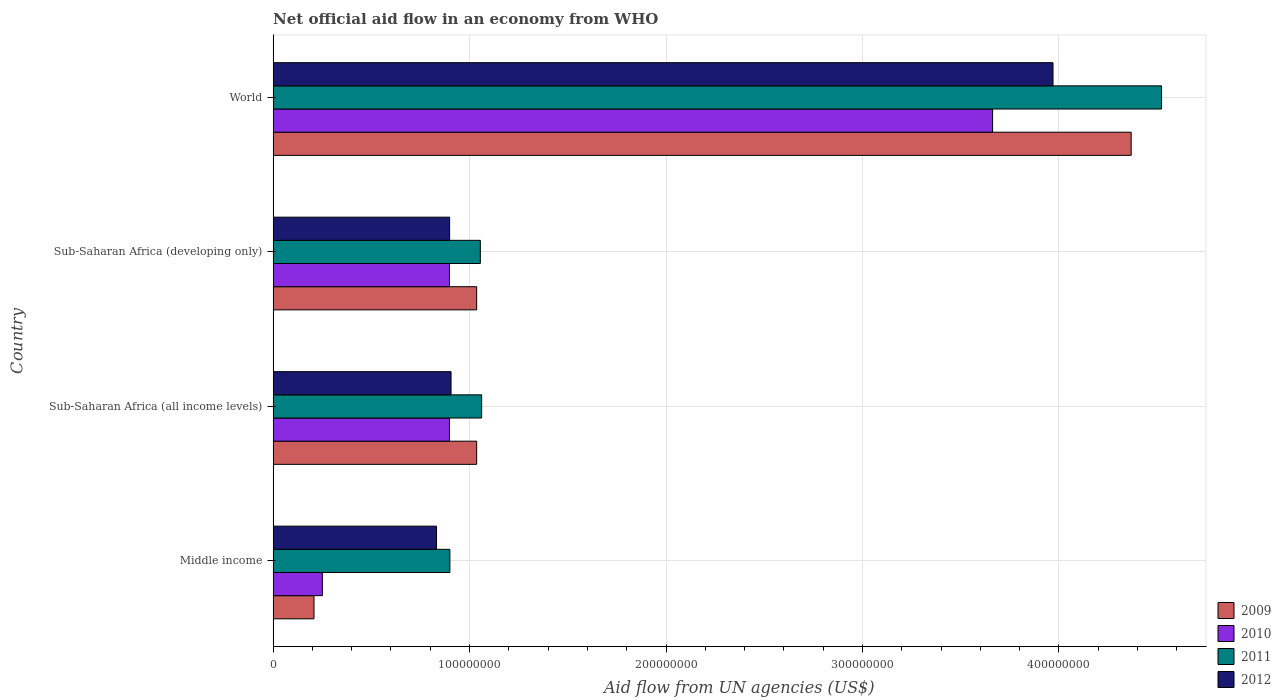How many different coloured bars are there?
Provide a short and direct response. 4. Are the number of bars on each tick of the Y-axis equal?
Provide a succinct answer. Yes. In how many cases, is the number of bars for a given country not equal to the number of legend labels?
Your response must be concise. 0. What is the net official aid flow in 2009 in Middle income?
Provide a short and direct response. 2.08e+07. Across all countries, what is the maximum net official aid flow in 2011?
Your response must be concise. 4.52e+08. Across all countries, what is the minimum net official aid flow in 2009?
Offer a terse response. 2.08e+07. In which country was the net official aid flow in 2009 minimum?
Your answer should be very brief. Middle income. What is the total net official aid flow in 2012 in the graph?
Provide a short and direct response. 6.61e+08. What is the difference between the net official aid flow in 2011 in Middle income and that in World?
Keep it short and to the point. -3.62e+08. What is the difference between the net official aid flow in 2011 in Middle income and the net official aid flow in 2010 in World?
Keep it short and to the point. -2.76e+08. What is the average net official aid flow in 2010 per country?
Provide a short and direct response. 1.43e+08. What is the difference between the net official aid flow in 2010 and net official aid flow in 2011 in Sub-Saharan Africa (developing only)?
Your answer should be very brief. -1.57e+07. What is the ratio of the net official aid flow in 2009 in Middle income to that in World?
Ensure brevity in your answer.  0.05. Is the net official aid flow in 2011 in Middle income less than that in World?
Give a very brief answer. Yes. Is the difference between the net official aid flow in 2010 in Sub-Saharan Africa (all income levels) and Sub-Saharan Africa (developing only) greater than the difference between the net official aid flow in 2011 in Sub-Saharan Africa (all income levels) and Sub-Saharan Africa (developing only)?
Provide a succinct answer. No. What is the difference between the highest and the second highest net official aid flow in 2012?
Provide a short and direct response. 3.06e+08. What is the difference between the highest and the lowest net official aid flow in 2009?
Your answer should be compact. 4.16e+08. In how many countries, is the net official aid flow in 2012 greater than the average net official aid flow in 2012 taken over all countries?
Your answer should be very brief. 1. Is the sum of the net official aid flow in 2012 in Sub-Saharan Africa (all income levels) and World greater than the maximum net official aid flow in 2009 across all countries?
Make the answer very short. Yes. What does the 4th bar from the top in World represents?
Offer a very short reply. 2009. What does the 1st bar from the bottom in Sub-Saharan Africa (developing only) represents?
Your answer should be very brief. 2009. Are all the bars in the graph horizontal?
Ensure brevity in your answer.  Yes. How many countries are there in the graph?
Offer a terse response. 4. Are the values on the major ticks of X-axis written in scientific E-notation?
Give a very brief answer. No. Does the graph contain grids?
Offer a terse response. Yes. What is the title of the graph?
Your response must be concise. Net official aid flow in an economy from WHO. Does "1986" appear as one of the legend labels in the graph?
Offer a very short reply. No. What is the label or title of the X-axis?
Ensure brevity in your answer.  Aid flow from UN agencies (US$). What is the Aid flow from UN agencies (US$) of 2009 in Middle income?
Ensure brevity in your answer.  2.08e+07. What is the Aid flow from UN agencies (US$) of 2010 in Middle income?
Keep it short and to the point. 2.51e+07. What is the Aid flow from UN agencies (US$) in 2011 in Middle income?
Make the answer very short. 9.00e+07. What is the Aid flow from UN agencies (US$) of 2012 in Middle income?
Your answer should be compact. 8.32e+07. What is the Aid flow from UN agencies (US$) of 2009 in Sub-Saharan Africa (all income levels)?
Your response must be concise. 1.04e+08. What is the Aid flow from UN agencies (US$) in 2010 in Sub-Saharan Africa (all income levels)?
Your answer should be compact. 8.98e+07. What is the Aid flow from UN agencies (US$) in 2011 in Sub-Saharan Africa (all income levels)?
Provide a short and direct response. 1.06e+08. What is the Aid flow from UN agencies (US$) in 2012 in Sub-Saharan Africa (all income levels)?
Your response must be concise. 9.06e+07. What is the Aid flow from UN agencies (US$) of 2009 in Sub-Saharan Africa (developing only)?
Give a very brief answer. 1.04e+08. What is the Aid flow from UN agencies (US$) of 2010 in Sub-Saharan Africa (developing only)?
Keep it short and to the point. 8.98e+07. What is the Aid flow from UN agencies (US$) in 2011 in Sub-Saharan Africa (developing only)?
Your answer should be very brief. 1.05e+08. What is the Aid flow from UN agencies (US$) of 2012 in Sub-Saharan Africa (developing only)?
Your answer should be compact. 8.98e+07. What is the Aid flow from UN agencies (US$) of 2009 in World?
Your answer should be compact. 4.37e+08. What is the Aid flow from UN agencies (US$) in 2010 in World?
Give a very brief answer. 3.66e+08. What is the Aid flow from UN agencies (US$) in 2011 in World?
Your response must be concise. 4.52e+08. What is the Aid flow from UN agencies (US$) of 2012 in World?
Provide a short and direct response. 3.97e+08. Across all countries, what is the maximum Aid flow from UN agencies (US$) in 2009?
Provide a short and direct response. 4.37e+08. Across all countries, what is the maximum Aid flow from UN agencies (US$) of 2010?
Your answer should be compact. 3.66e+08. Across all countries, what is the maximum Aid flow from UN agencies (US$) of 2011?
Your answer should be very brief. 4.52e+08. Across all countries, what is the maximum Aid flow from UN agencies (US$) of 2012?
Provide a short and direct response. 3.97e+08. Across all countries, what is the minimum Aid flow from UN agencies (US$) of 2009?
Provide a short and direct response. 2.08e+07. Across all countries, what is the minimum Aid flow from UN agencies (US$) of 2010?
Give a very brief answer. 2.51e+07. Across all countries, what is the minimum Aid flow from UN agencies (US$) in 2011?
Your answer should be compact. 9.00e+07. Across all countries, what is the minimum Aid flow from UN agencies (US$) of 2012?
Ensure brevity in your answer.  8.32e+07. What is the total Aid flow from UN agencies (US$) of 2009 in the graph?
Provide a short and direct response. 6.65e+08. What is the total Aid flow from UN agencies (US$) in 2010 in the graph?
Ensure brevity in your answer.  5.71e+08. What is the total Aid flow from UN agencies (US$) in 2011 in the graph?
Keep it short and to the point. 7.54e+08. What is the total Aid flow from UN agencies (US$) in 2012 in the graph?
Ensure brevity in your answer.  6.61e+08. What is the difference between the Aid flow from UN agencies (US$) of 2009 in Middle income and that in Sub-Saharan Africa (all income levels)?
Give a very brief answer. -8.28e+07. What is the difference between the Aid flow from UN agencies (US$) of 2010 in Middle income and that in Sub-Saharan Africa (all income levels)?
Provide a short and direct response. -6.47e+07. What is the difference between the Aid flow from UN agencies (US$) in 2011 in Middle income and that in Sub-Saharan Africa (all income levels)?
Give a very brief answer. -1.62e+07. What is the difference between the Aid flow from UN agencies (US$) of 2012 in Middle income and that in Sub-Saharan Africa (all income levels)?
Offer a very short reply. -7.39e+06. What is the difference between the Aid flow from UN agencies (US$) in 2009 in Middle income and that in Sub-Saharan Africa (developing only)?
Keep it short and to the point. -8.28e+07. What is the difference between the Aid flow from UN agencies (US$) of 2010 in Middle income and that in Sub-Saharan Africa (developing only)?
Provide a succinct answer. -6.47e+07. What is the difference between the Aid flow from UN agencies (US$) in 2011 in Middle income and that in Sub-Saharan Africa (developing only)?
Provide a short and direct response. -1.55e+07. What is the difference between the Aid flow from UN agencies (US$) of 2012 in Middle income and that in Sub-Saharan Africa (developing only)?
Ensure brevity in your answer.  -6.67e+06. What is the difference between the Aid flow from UN agencies (US$) of 2009 in Middle income and that in World?
Make the answer very short. -4.16e+08. What is the difference between the Aid flow from UN agencies (US$) in 2010 in Middle income and that in World?
Provide a succinct answer. -3.41e+08. What is the difference between the Aid flow from UN agencies (US$) of 2011 in Middle income and that in World?
Offer a terse response. -3.62e+08. What is the difference between the Aid flow from UN agencies (US$) of 2012 in Middle income and that in World?
Your answer should be very brief. -3.14e+08. What is the difference between the Aid flow from UN agencies (US$) of 2009 in Sub-Saharan Africa (all income levels) and that in Sub-Saharan Africa (developing only)?
Make the answer very short. 0. What is the difference between the Aid flow from UN agencies (US$) in 2011 in Sub-Saharan Africa (all income levels) and that in Sub-Saharan Africa (developing only)?
Your answer should be very brief. 6.70e+05. What is the difference between the Aid flow from UN agencies (US$) of 2012 in Sub-Saharan Africa (all income levels) and that in Sub-Saharan Africa (developing only)?
Provide a short and direct response. 7.20e+05. What is the difference between the Aid flow from UN agencies (US$) of 2009 in Sub-Saharan Africa (all income levels) and that in World?
Ensure brevity in your answer.  -3.33e+08. What is the difference between the Aid flow from UN agencies (US$) of 2010 in Sub-Saharan Africa (all income levels) and that in World?
Offer a terse response. -2.76e+08. What is the difference between the Aid flow from UN agencies (US$) of 2011 in Sub-Saharan Africa (all income levels) and that in World?
Provide a succinct answer. -3.46e+08. What is the difference between the Aid flow from UN agencies (US$) of 2012 in Sub-Saharan Africa (all income levels) and that in World?
Your answer should be compact. -3.06e+08. What is the difference between the Aid flow from UN agencies (US$) in 2009 in Sub-Saharan Africa (developing only) and that in World?
Offer a terse response. -3.33e+08. What is the difference between the Aid flow from UN agencies (US$) of 2010 in Sub-Saharan Africa (developing only) and that in World?
Offer a terse response. -2.76e+08. What is the difference between the Aid flow from UN agencies (US$) in 2011 in Sub-Saharan Africa (developing only) and that in World?
Give a very brief answer. -3.47e+08. What is the difference between the Aid flow from UN agencies (US$) in 2012 in Sub-Saharan Africa (developing only) and that in World?
Provide a short and direct response. -3.07e+08. What is the difference between the Aid flow from UN agencies (US$) of 2009 in Middle income and the Aid flow from UN agencies (US$) of 2010 in Sub-Saharan Africa (all income levels)?
Make the answer very short. -6.90e+07. What is the difference between the Aid flow from UN agencies (US$) in 2009 in Middle income and the Aid flow from UN agencies (US$) in 2011 in Sub-Saharan Africa (all income levels)?
Ensure brevity in your answer.  -8.54e+07. What is the difference between the Aid flow from UN agencies (US$) in 2009 in Middle income and the Aid flow from UN agencies (US$) in 2012 in Sub-Saharan Africa (all income levels)?
Ensure brevity in your answer.  -6.98e+07. What is the difference between the Aid flow from UN agencies (US$) in 2010 in Middle income and the Aid flow from UN agencies (US$) in 2011 in Sub-Saharan Africa (all income levels)?
Your response must be concise. -8.11e+07. What is the difference between the Aid flow from UN agencies (US$) in 2010 in Middle income and the Aid flow from UN agencies (US$) in 2012 in Sub-Saharan Africa (all income levels)?
Make the answer very short. -6.55e+07. What is the difference between the Aid flow from UN agencies (US$) of 2011 in Middle income and the Aid flow from UN agencies (US$) of 2012 in Sub-Saharan Africa (all income levels)?
Make the answer very short. -5.90e+05. What is the difference between the Aid flow from UN agencies (US$) of 2009 in Middle income and the Aid flow from UN agencies (US$) of 2010 in Sub-Saharan Africa (developing only)?
Your response must be concise. -6.90e+07. What is the difference between the Aid flow from UN agencies (US$) of 2009 in Middle income and the Aid flow from UN agencies (US$) of 2011 in Sub-Saharan Africa (developing only)?
Make the answer very short. -8.47e+07. What is the difference between the Aid flow from UN agencies (US$) in 2009 in Middle income and the Aid flow from UN agencies (US$) in 2012 in Sub-Saharan Africa (developing only)?
Provide a short and direct response. -6.90e+07. What is the difference between the Aid flow from UN agencies (US$) of 2010 in Middle income and the Aid flow from UN agencies (US$) of 2011 in Sub-Saharan Africa (developing only)?
Provide a succinct answer. -8.04e+07. What is the difference between the Aid flow from UN agencies (US$) in 2010 in Middle income and the Aid flow from UN agencies (US$) in 2012 in Sub-Saharan Africa (developing only)?
Offer a terse response. -6.48e+07. What is the difference between the Aid flow from UN agencies (US$) of 2011 in Middle income and the Aid flow from UN agencies (US$) of 2012 in Sub-Saharan Africa (developing only)?
Your answer should be compact. 1.30e+05. What is the difference between the Aid flow from UN agencies (US$) of 2009 in Middle income and the Aid flow from UN agencies (US$) of 2010 in World?
Your answer should be compact. -3.45e+08. What is the difference between the Aid flow from UN agencies (US$) in 2009 in Middle income and the Aid flow from UN agencies (US$) in 2011 in World?
Make the answer very short. -4.31e+08. What is the difference between the Aid flow from UN agencies (US$) of 2009 in Middle income and the Aid flow from UN agencies (US$) of 2012 in World?
Ensure brevity in your answer.  -3.76e+08. What is the difference between the Aid flow from UN agencies (US$) in 2010 in Middle income and the Aid flow from UN agencies (US$) in 2011 in World?
Ensure brevity in your answer.  -4.27e+08. What is the difference between the Aid flow from UN agencies (US$) in 2010 in Middle income and the Aid flow from UN agencies (US$) in 2012 in World?
Offer a very short reply. -3.72e+08. What is the difference between the Aid flow from UN agencies (US$) of 2011 in Middle income and the Aid flow from UN agencies (US$) of 2012 in World?
Your answer should be compact. -3.07e+08. What is the difference between the Aid flow from UN agencies (US$) of 2009 in Sub-Saharan Africa (all income levels) and the Aid flow from UN agencies (US$) of 2010 in Sub-Saharan Africa (developing only)?
Make the answer very short. 1.39e+07. What is the difference between the Aid flow from UN agencies (US$) in 2009 in Sub-Saharan Africa (all income levels) and the Aid flow from UN agencies (US$) in 2011 in Sub-Saharan Africa (developing only)?
Your answer should be compact. -1.86e+06. What is the difference between the Aid flow from UN agencies (US$) of 2009 in Sub-Saharan Africa (all income levels) and the Aid flow from UN agencies (US$) of 2012 in Sub-Saharan Africa (developing only)?
Your response must be concise. 1.38e+07. What is the difference between the Aid flow from UN agencies (US$) in 2010 in Sub-Saharan Africa (all income levels) and the Aid flow from UN agencies (US$) in 2011 in Sub-Saharan Africa (developing only)?
Offer a very short reply. -1.57e+07. What is the difference between the Aid flow from UN agencies (US$) of 2010 in Sub-Saharan Africa (all income levels) and the Aid flow from UN agencies (US$) of 2012 in Sub-Saharan Africa (developing only)?
Provide a succinct answer. -9.00e+04. What is the difference between the Aid flow from UN agencies (US$) in 2011 in Sub-Saharan Africa (all income levels) and the Aid flow from UN agencies (US$) in 2012 in Sub-Saharan Africa (developing only)?
Your answer should be compact. 1.63e+07. What is the difference between the Aid flow from UN agencies (US$) in 2009 in Sub-Saharan Africa (all income levels) and the Aid flow from UN agencies (US$) in 2010 in World?
Your answer should be very brief. -2.63e+08. What is the difference between the Aid flow from UN agencies (US$) of 2009 in Sub-Saharan Africa (all income levels) and the Aid flow from UN agencies (US$) of 2011 in World?
Provide a short and direct response. -3.49e+08. What is the difference between the Aid flow from UN agencies (US$) of 2009 in Sub-Saharan Africa (all income levels) and the Aid flow from UN agencies (US$) of 2012 in World?
Your response must be concise. -2.93e+08. What is the difference between the Aid flow from UN agencies (US$) in 2010 in Sub-Saharan Africa (all income levels) and the Aid flow from UN agencies (US$) in 2011 in World?
Your answer should be very brief. -3.62e+08. What is the difference between the Aid flow from UN agencies (US$) of 2010 in Sub-Saharan Africa (all income levels) and the Aid flow from UN agencies (US$) of 2012 in World?
Your answer should be compact. -3.07e+08. What is the difference between the Aid flow from UN agencies (US$) of 2011 in Sub-Saharan Africa (all income levels) and the Aid flow from UN agencies (US$) of 2012 in World?
Offer a very short reply. -2.91e+08. What is the difference between the Aid flow from UN agencies (US$) in 2009 in Sub-Saharan Africa (developing only) and the Aid flow from UN agencies (US$) in 2010 in World?
Make the answer very short. -2.63e+08. What is the difference between the Aid flow from UN agencies (US$) in 2009 in Sub-Saharan Africa (developing only) and the Aid flow from UN agencies (US$) in 2011 in World?
Make the answer very short. -3.49e+08. What is the difference between the Aid flow from UN agencies (US$) in 2009 in Sub-Saharan Africa (developing only) and the Aid flow from UN agencies (US$) in 2012 in World?
Your response must be concise. -2.93e+08. What is the difference between the Aid flow from UN agencies (US$) in 2010 in Sub-Saharan Africa (developing only) and the Aid flow from UN agencies (US$) in 2011 in World?
Your answer should be compact. -3.62e+08. What is the difference between the Aid flow from UN agencies (US$) in 2010 in Sub-Saharan Africa (developing only) and the Aid flow from UN agencies (US$) in 2012 in World?
Your response must be concise. -3.07e+08. What is the difference between the Aid flow from UN agencies (US$) of 2011 in Sub-Saharan Africa (developing only) and the Aid flow from UN agencies (US$) of 2012 in World?
Provide a short and direct response. -2.92e+08. What is the average Aid flow from UN agencies (US$) in 2009 per country?
Ensure brevity in your answer.  1.66e+08. What is the average Aid flow from UN agencies (US$) of 2010 per country?
Your answer should be compact. 1.43e+08. What is the average Aid flow from UN agencies (US$) in 2011 per country?
Your response must be concise. 1.88e+08. What is the average Aid flow from UN agencies (US$) in 2012 per country?
Ensure brevity in your answer.  1.65e+08. What is the difference between the Aid flow from UN agencies (US$) in 2009 and Aid flow from UN agencies (US$) in 2010 in Middle income?
Give a very brief answer. -4.27e+06. What is the difference between the Aid flow from UN agencies (US$) of 2009 and Aid flow from UN agencies (US$) of 2011 in Middle income?
Keep it short and to the point. -6.92e+07. What is the difference between the Aid flow from UN agencies (US$) in 2009 and Aid flow from UN agencies (US$) in 2012 in Middle income?
Your answer should be very brief. -6.24e+07. What is the difference between the Aid flow from UN agencies (US$) in 2010 and Aid flow from UN agencies (US$) in 2011 in Middle income?
Ensure brevity in your answer.  -6.49e+07. What is the difference between the Aid flow from UN agencies (US$) in 2010 and Aid flow from UN agencies (US$) in 2012 in Middle income?
Provide a succinct answer. -5.81e+07. What is the difference between the Aid flow from UN agencies (US$) of 2011 and Aid flow from UN agencies (US$) of 2012 in Middle income?
Ensure brevity in your answer.  6.80e+06. What is the difference between the Aid flow from UN agencies (US$) of 2009 and Aid flow from UN agencies (US$) of 2010 in Sub-Saharan Africa (all income levels)?
Provide a succinct answer. 1.39e+07. What is the difference between the Aid flow from UN agencies (US$) of 2009 and Aid flow from UN agencies (US$) of 2011 in Sub-Saharan Africa (all income levels)?
Make the answer very short. -2.53e+06. What is the difference between the Aid flow from UN agencies (US$) of 2009 and Aid flow from UN agencies (US$) of 2012 in Sub-Saharan Africa (all income levels)?
Keep it short and to the point. 1.30e+07. What is the difference between the Aid flow from UN agencies (US$) of 2010 and Aid flow from UN agencies (US$) of 2011 in Sub-Saharan Africa (all income levels)?
Your answer should be very brief. -1.64e+07. What is the difference between the Aid flow from UN agencies (US$) of 2010 and Aid flow from UN agencies (US$) of 2012 in Sub-Saharan Africa (all income levels)?
Your answer should be very brief. -8.10e+05. What is the difference between the Aid flow from UN agencies (US$) of 2011 and Aid flow from UN agencies (US$) of 2012 in Sub-Saharan Africa (all income levels)?
Your answer should be very brief. 1.56e+07. What is the difference between the Aid flow from UN agencies (US$) in 2009 and Aid flow from UN agencies (US$) in 2010 in Sub-Saharan Africa (developing only)?
Your response must be concise. 1.39e+07. What is the difference between the Aid flow from UN agencies (US$) of 2009 and Aid flow from UN agencies (US$) of 2011 in Sub-Saharan Africa (developing only)?
Keep it short and to the point. -1.86e+06. What is the difference between the Aid flow from UN agencies (US$) of 2009 and Aid flow from UN agencies (US$) of 2012 in Sub-Saharan Africa (developing only)?
Provide a succinct answer. 1.38e+07. What is the difference between the Aid flow from UN agencies (US$) in 2010 and Aid flow from UN agencies (US$) in 2011 in Sub-Saharan Africa (developing only)?
Offer a terse response. -1.57e+07. What is the difference between the Aid flow from UN agencies (US$) of 2011 and Aid flow from UN agencies (US$) of 2012 in Sub-Saharan Africa (developing only)?
Offer a terse response. 1.56e+07. What is the difference between the Aid flow from UN agencies (US$) of 2009 and Aid flow from UN agencies (US$) of 2010 in World?
Give a very brief answer. 7.06e+07. What is the difference between the Aid flow from UN agencies (US$) in 2009 and Aid flow from UN agencies (US$) in 2011 in World?
Your answer should be very brief. -1.55e+07. What is the difference between the Aid flow from UN agencies (US$) in 2009 and Aid flow from UN agencies (US$) in 2012 in World?
Your response must be concise. 3.98e+07. What is the difference between the Aid flow from UN agencies (US$) of 2010 and Aid flow from UN agencies (US$) of 2011 in World?
Offer a very short reply. -8.60e+07. What is the difference between the Aid flow from UN agencies (US$) of 2010 and Aid flow from UN agencies (US$) of 2012 in World?
Provide a short and direct response. -3.08e+07. What is the difference between the Aid flow from UN agencies (US$) of 2011 and Aid flow from UN agencies (US$) of 2012 in World?
Your answer should be very brief. 5.53e+07. What is the ratio of the Aid flow from UN agencies (US$) in 2009 in Middle income to that in Sub-Saharan Africa (all income levels)?
Ensure brevity in your answer.  0.2. What is the ratio of the Aid flow from UN agencies (US$) in 2010 in Middle income to that in Sub-Saharan Africa (all income levels)?
Give a very brief answer. 0.28. What is the ratio of the Aid flow from UN agencies (US$) in 2011 in Middle income to that in Sub-Saharan Africa (all income levels)?
Ensure brevity in your answer.  0.85. What is the ratio of the Aid flow from UN agencies (US$) of 2012 in Middle income to that in Sub-Saharan Africa (all income levels)?
Give a very brief answer. 0.92. What is the ratio of the Aid flow from UN agencies (US$) of 2009 in Middle income to that in Sub-Saharan Africa (developing only)?
Make the answer very short. 0.2. What is the ratio of the Aid flow from UN agencies (US$) of 2010 in Middle income to that in Sub-Saharan Africa (developing only)?
Ensure brevity in your answer.  0.28. What is the ratio of the Aid flow from UN agencies (US$) of 2011 in Middle income to that in Sub-Saharan Africa (developing only)?
Offer a terse response. 0.85. What is the ratio of the Aid flow from UN agencies (US$) in 2012 in Middle income to that in Sub-Saharan Africa (developing only)?
Your response must be concise. 0.93. What is the ratio of the Aid flow from UN agencies (US$) in 2009 in Middle income to that in World?
Make the answer very short. 0.05. What is the ratio of the Aid flow from UN agencies (US$) of 2010 in Middle income to that in World?
Keep it short and to the point. 0.07. What is the ratio of the Aid flow from UN agencies (US$) in 2011 in Middle income to that in World?
Your answer should be very brief. 0.2. What is the ratio of the Aid flow from UN agencies (US$) of 2012 in Middle income to that in World?
Ensure brevity in your answer.  0.21. What is the ratio of the Aid flow from UN agencies (US$) of 2009 in Sub-Saharan Africa (all income levels) to that in Sub-Saharan Africa (developing only)?
Your response must be concise. 1. What is the ratio of the Aid flow from UN agencies (US$) of 2011 in Sub-Saharan Africa (all income levels) to that in Sub-Saharan Africa (developing only)?
Your answer should be compact. 1.01. What is the ratio of the Aid flow from UN agencies (US$) of 2009 in Sub-Saharan Africa (all income levels) to that in World?
Keep it short and to the point. 0.24. What is the ratio of the Aid flow from UN agencies (US$) in 2010 in Sub-Saharan Africa (all income levels) to that in World?
Make the answer very short. 0.25. What is the ratio of the Aid flow from UN agencies (US$) in 2011 in Sub-Saharan Africa (all income levels) to that in World?
Your response must be concise. 0.23. What is the ratio of the Aid flow from UN agencies (US$) in 2012 in Sub-Saharan Africa (all income levels) to that in World?
Your answer should be very brief. 0.23. What is the ratio of the Aid flow from UN agencies (US$) in 2009 in Sub-Saharan Africa (developing only) to that in World?
Offer a very short reply. 0.24. What is the ratio of the Aid flow from UN agencies (US$) in 2010 in Sub-Saharan Africa (developing only) to that in World?
Offer a very short reply. 0.25. What is the ratio of the Aid flow from UN agencies (US$) in 2011 in Sub-Saharan Africa (developing only) to that in World?
Give a very brief answer. 0.23. What is the ratio of the Aid flow from UN agencies (US$) in 2012 in Sub-Saharan Africa (developing only) to that in World?
Provide a short and direct response. 0.23. What is the difference between the highest and the second highest Aid flow from UN agencies (US$) in 2009?
Offer a very short reply. 3.33e+08. What is the difference between the highest and the second highest Aid flow from UN agencies (US$) of 2010?
Make the answer very short. 2.76e+08. What is the difference between the highest and the second highest Aid flow from UN agencies (US$) in 2011?
Your answer should be very brief. 3.46e+08. What is the difference between the highest and the second highest Aid flow from UN agencies (US$) in 2012?
Keep it short and to the point. 3.06e+08. What is the difference between the highest and the lowest Aid flow from UN agencies (US$) in 2009?
Keep it short and to the point. 4.16e+08. What is the difference between the highest and the lowest Aid flow from UN agencies (US$) in 2010?
Provide a short and direct response. 3.41e+08. What is the difference between the highest and the lowest Aid flow from UN agencies (US$) of 2011?
Your answer should be compact. 3.62e+08. What is the difference between the highest and the lowest Aid flow from UN agencies (US$) in 2012?
Provide a short and direct response. 3.14e+08. 